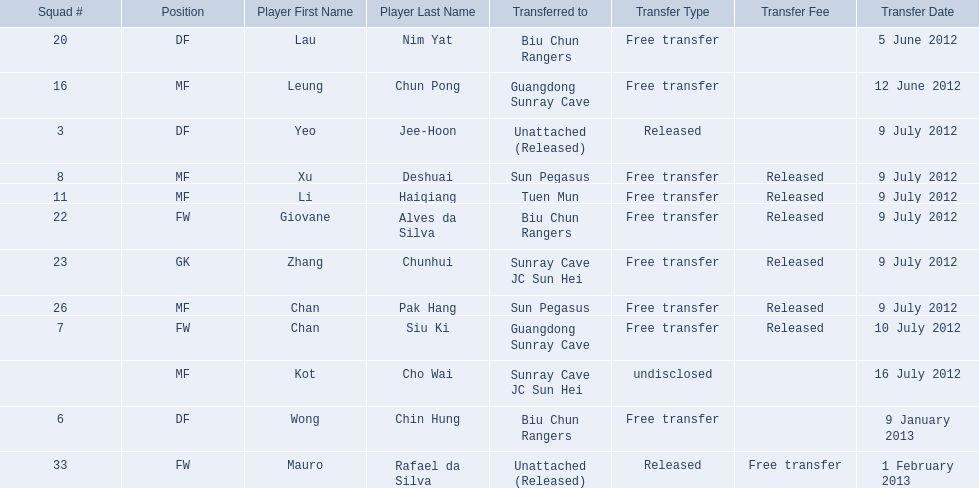Which players played during the 2012-13 south china aa season? Lau Nim Yat, Leung Chun Pong, Yeo Jee-Hoon, Xu Deshuai, Li Haiqiang, Giovane Alves da Silva, Zhang Chunhui, Chan Pak Hang, Chan Siu Ki, Kot Cho Wai, Wong Chin Hung, Mauro Rafael da Silva. Of these, which were free transfers that were not released? Lau Nim Yat, Leung Chun Pong, Wong Chin Hung, Mauro Rafael da Silva. Of these, which were in squad # 6? Wong Chin Hung. What was the date of his transfer? 9 January 2013. 